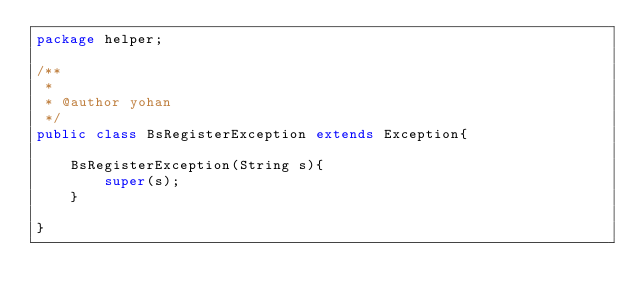Convert code to text. <code><loc_0><loc_0><loc_500><loc_500><_Java_>package helper;

/**
 *
 * @author yohan
 */
public class BsRegisterException extends Exception{
    
    BsRegisterException(String s){
        super(s);
    }
    
}
</code> 